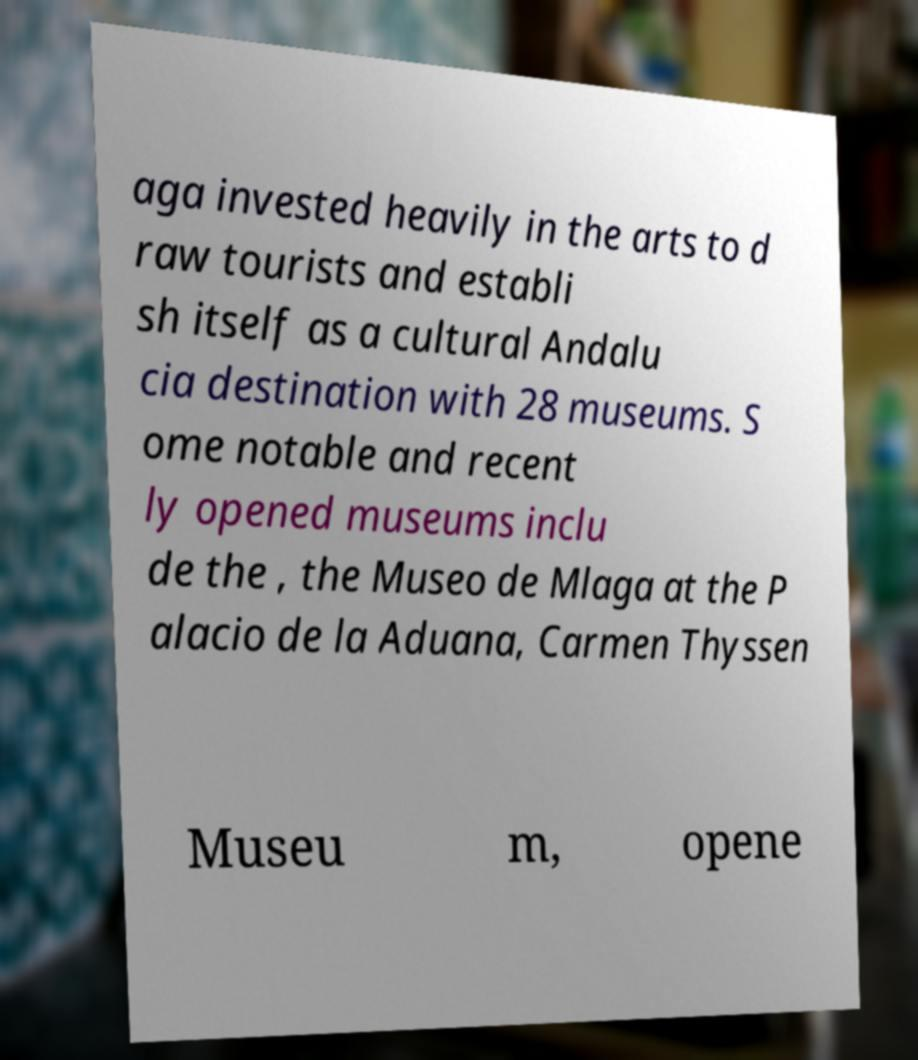I need the written content from this picture converted into text. Can you do that? aga invested heavily in the arts to d raw tourists and establi sh itself as a cultural Andalu cia destination with 28 museums. S ome notable and recent ly opened museums inclu de the , the Museo de Mlaga at the P alacio de la Aduana, Carmen Thyssen Museu m, opene 